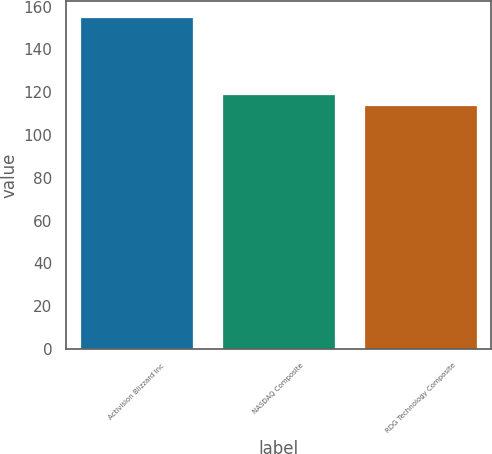Convert chart to OTSL. <chart><loc_0><loc_0><loc_500><loc_500><bar_chart><fcel>Activision Blizzard Inc<fcel>NASDAQ Composite<fcel>RDG Technology Composite<nl><fcel>154.97<fcel>118.97<fcel>114.09<nl></chart> 